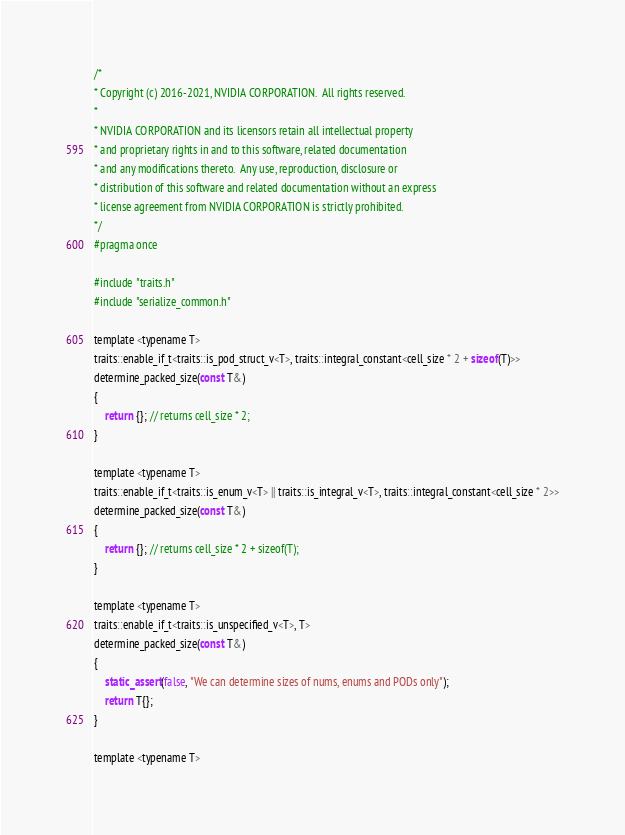Convert code to text. <code><loc_0><loc_0><loc_500><loc_500><_C_>/*
* Copyright (c) 2016-2021, NVIDIA CORPORATION.  All rights reserved.
*
* NVIDIA CORPORATION and its licensors retain all intellectual property
* and proprietary rights in and to this software, related documentation
* and any modifications thereto.  Any use, reproduction, disclosure or
* distribution of this software and related documentation without an express
* license agreement from NVIDIA CORPORATION is strictly prohibited.
*/
#pragma once

#include "traits.h"
#include "serialize_common.h"

template <typename T>
traits::enable_if_t<traits::is_pod_struct_v<T>, traits::integral_constant<cell_size * 2 + sizeof(T)>>
determine_packed_size(const T&)
{
	return {}; // returns cell_size * 2;
}

template <typename T>
traits::enable_if_t<traits::is_enum_v<T> || traits::is_integral_v<T>, traits::integral_constant<cell_size * 2>>
determine_packed_size(const T&)
{
	return {}; // returns cell_size * 2 + sizeof(T);
}

template <typename T>
traits::enable_if_t<traits::is_unspecified_v<T>, T>
determine_packed_size(const T&)
{
	static_assert(false, "We can determine sizes of nums, enums and PODs only");
	return T{};
}

template <typename T></code> 